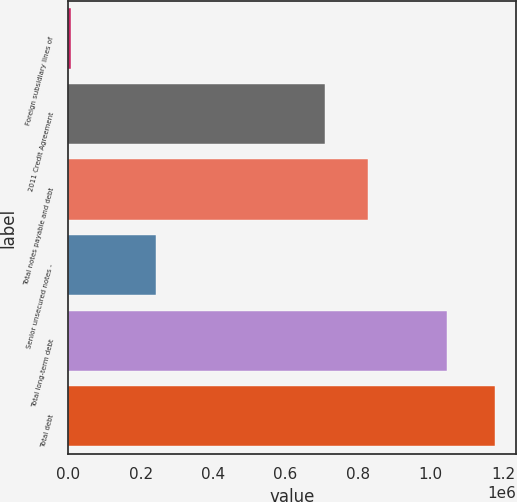Convert chart to OTSL. <chart><loc_0><loc_0><loc_500><loc_500><bar_chart><fcel>Foreign subsidiary lines of<fcel>2011 Credit Agreement<fcel>Total notes payable and debt<fcel>Senior unsecured notes -<fcel>Total long-term debt<fcel>Total debt<nl><fcel>7781<fcel>709781<fcel>826781<fcel>241781<fcel>1.045e+06<fcel>1.17778e+06<nl></chart> 